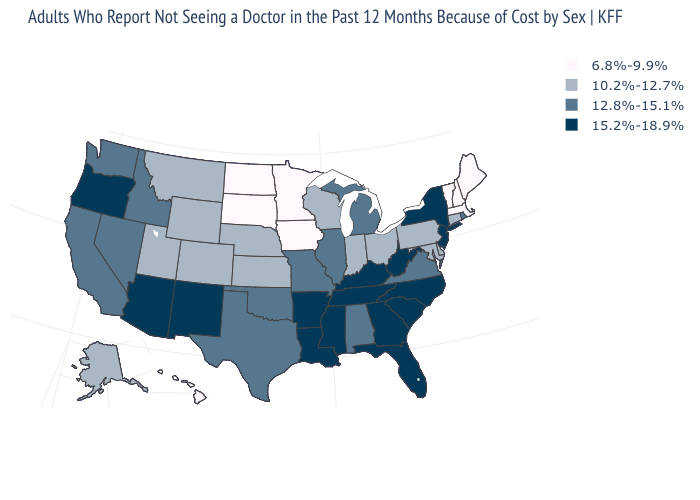Does New York have a higher value than North Carolina?
Concise answer only. No. What is the value of Colorado?
Be succinct. 10.2%-12.7%. What is the lowest value in the West?
Answer briefly. 6.8%-9.9%. Name the states that have a value in the range 10.2%-12.7%?
Quick response, please. Alaska, Colorado, Connecticut, Delaware, Indiana, Kansas, Maryland, Montana, Nebraska, Ohio, Pennsylvania, Utah, Wisconsin, Wyoming. What is the value of Arizona?
Short answer required. 15.2%-18.9%. How many symbols are there in the legend?
Keep it brief. 4. Among the states that border Texas , which have the highest value?
Keep it brief. Arkansas, Louisiana, New Mexico. Does Vermont have the lowest value in the USA?
Quick response, please. Yes. Among the states that border Mississippi , does Alabama have the highest value?
Quick response, please. No. Does Wyoming have the lowest value in the West?
Give a very brief answer. No. Name the states that have a value in the range 12.8%-15.1%?
Short answer required. Alabama, California, Idaho, Illinois, Michigan, Missouri, Nevada, Oklahoma, Rhode Island, Texas, Virginia, Washington. Name the states that have a value in the range 10.2%-12.7%?
Concise answer only. Alaska, Colorado, Connecticut, Delaware, Indiana, Kansas, Maryland, Montana, Nebraska, Ohio, Pennsylvania, Utah, Wisconsin, Wyoming. Is the legend a continuous bar?
Give a very brief answer. No. What is the value of Kentucky?
Give a very brief answer. 15.2%-18.9%. Name the states that have a value in the range 15.2%-18.9%?
Answer briefly. Arizona, Arkansas, Florida, Georgia, Kentucky, Louisiana, Mississippi, New Jersey, New Mexico, New York, North Carolina, Oregon, South Carolina, Tennessee, West Virginia. 